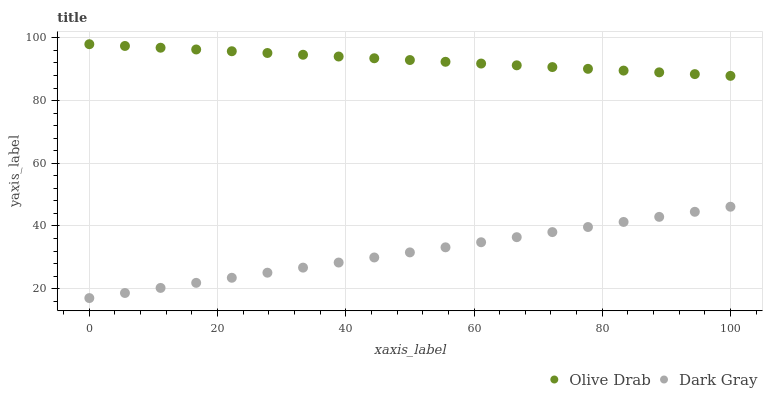Does Dark Gray have the minimum area under the curve?
Answer yes or no. Yes. Does Olive Drab have the maximum area under the curve?
Answer yes or no. Yes. Does Olive Drab have the minimum area under the curve?
Answer yes or no. No. Is Dark Gray the smoothest?
Answer yes or no. Yes. Is Olive Drab the roughest?
Answer yes or no. Yes. Is Olive Drab the smoothest?
Answer yes or no. No. Does Dark Gray have the lowest value?
Answer yes or no. Yes. Does Olive Drab have the lowest value?
Answer yes or no. No. Does Olive Drab have the highest value?
Answer yes or no. Yes. Is Dark Gray less than Olive Drab?
Answer yes or no. Yes. Is Olive Drab greater than Dark Gray?
Answer yes or no. Yes. Does Dark Gray intersect Olive Drab?
Answer yes or no. No. 